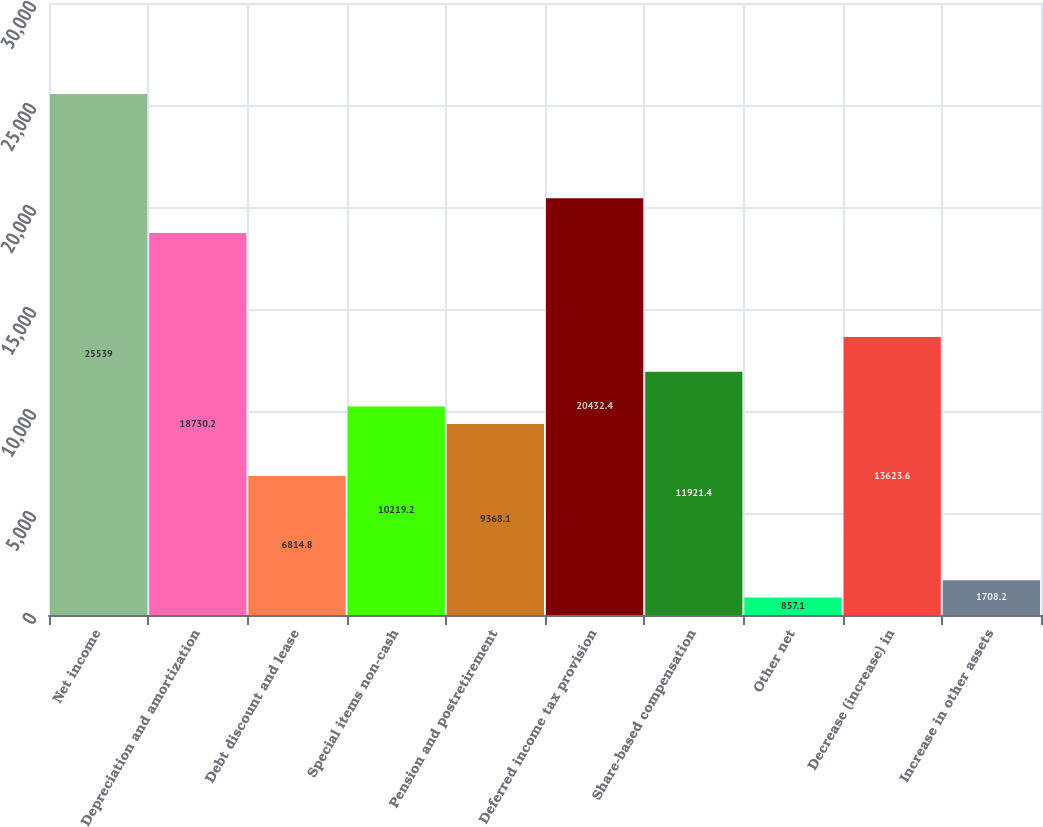Convert chart to OTSL. <chart><loc_0><loc_0><loc_500><loc_500><bar_chart><fcel>Net income<fcel>Depreciation and amortization<fcel>Debt discount and lease<fcel>Special items non-cash<fcel>Pension and postretirement<fcel>Deferred income tax provision<fcel>Share-based compensation<fcel>Other net<fcel>Decrease (increase) in<fcel>Increase in other assets<nl><fcel>25539<fcel>18730.2<fcel>6814.8<fcel>10219.2<fcel>9368.1<fcel>20432.4<fcel>11921.4<fcel>857.1<fcel>13623.6<fcel>1708.2<nl></chart> 